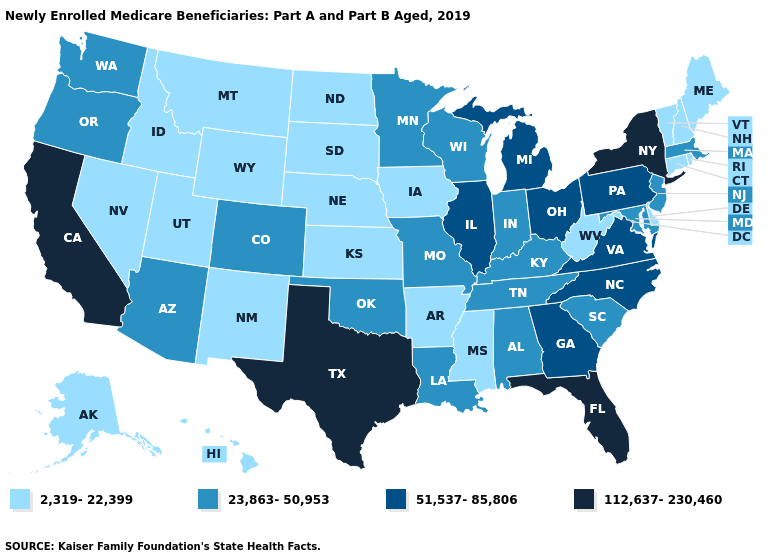Does Washington have the same value as New Mexico?
Quick response, please. No. What is the lowest value in the South?
Quick response, please. 2,319-22,399. What is the value of Louisiana?
Be succinct. 23,863-50,953. Name the states that have a value in the range 112,637-230,460?
Be succinct. California, Florida, New York, Texas. What is the value of Arkansas?
Be succinct. 2,319-22,399. What is the highest value in states that border Arizona?
Keep it brief. 112,637-230,460. Does Vermont have a higher value than West Virginia?
Concise answer only. No. Which states have the lowest value in the USA?
Be succinct. Alaska, Arkansas, Connecticut, Delaware, Hawaii, Idaho, Iowa, Kansas, Maine, Mississippi, Montana, Nebraska, Nevada, New Hampshire, New Mexico, North Dakota, Rhode Island, South Dakota, Utah, Vermont, West Virginia, Wyoming. Which states hav the highest value in the South?
Concise answer only. Florida, Texas. Among the states that border California , does Nevada have the highest value?
Be succinct. No. Does Connecticut have the same value as Missouri?
Answer briefly. No. Is the legend a continuous bar?
Short answer required. No. Does Arizona have a lower value than New Hampshire?
Answer briefly. No. What is the value of South Carolina?
Quick response, please. 23,863-50,953. Does the map have missing data?
Quick response, please. No. 